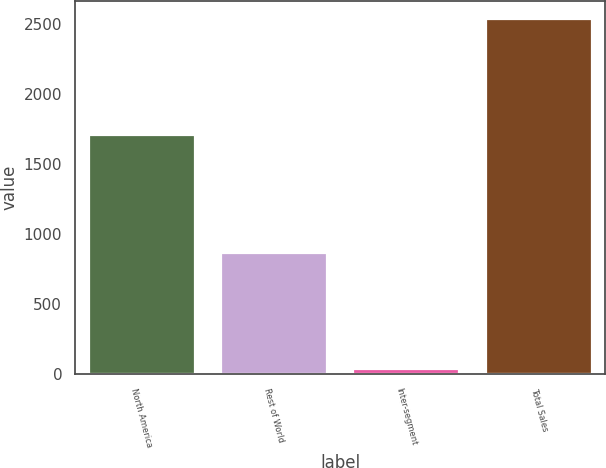Convert chart. <chart><loc_0><loc_0><loc_500><loc_500><bar_chart><fcel>North America<fcel>Rest of World<fcel>Inter-segment<fcel>Total Sales<nl><fcel>1703<fcel>866.1<fcel>32.6<fcel>2536.5<nl></chart> 